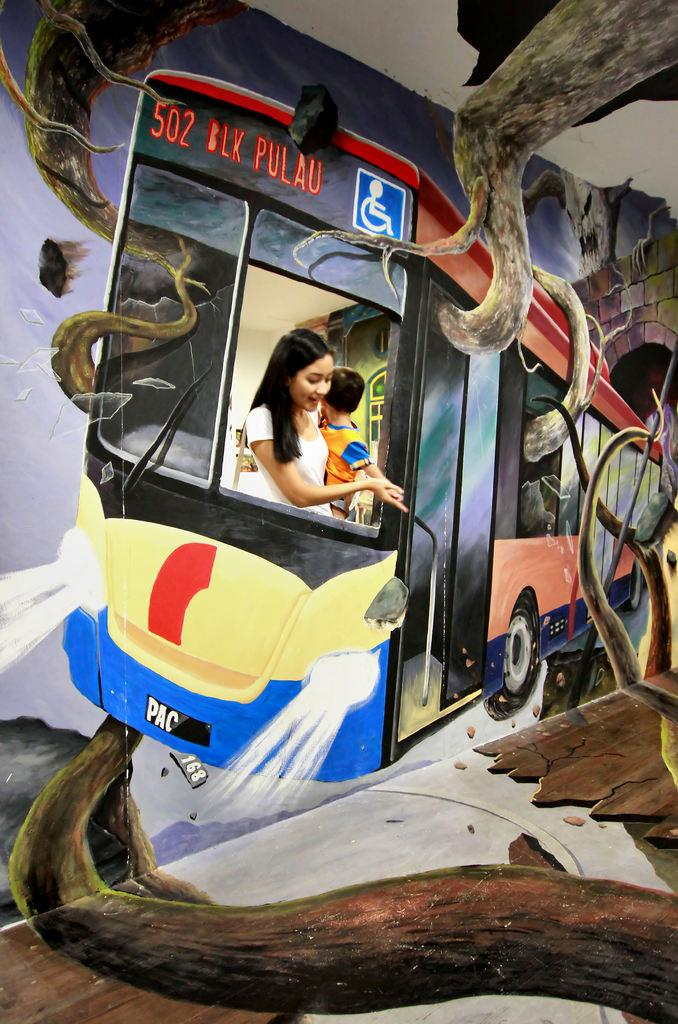What type of art can be seen on the wall in the image? There is an art design on the wall in the image, specifically a bus painting art. Who is present in the image near the bus window? A woman and a small boy are standing at the bus window. What is the relationship between the woman and the boy in the image? The facts provided do not specify the relationship between the woman and the boy. What type of gold jewelry is the woman wearing in the image? There is no mention of gold jewelry or any jewelry in the image. 